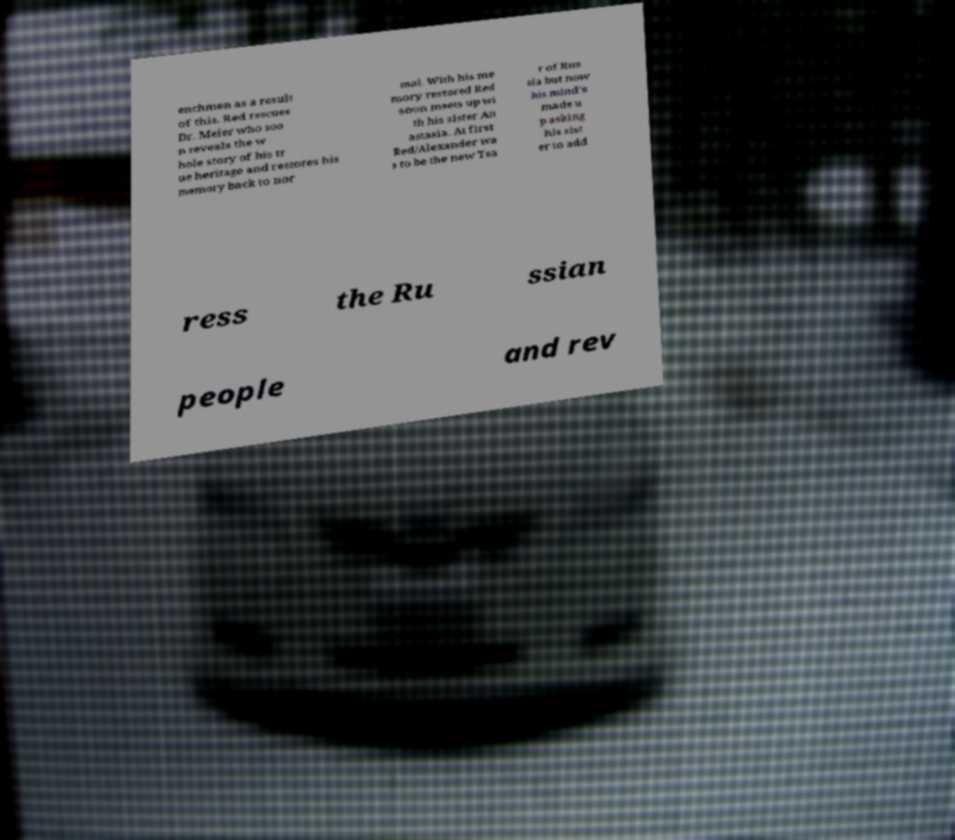Please identify and transcribe the text found in this image. enchmen as a result of this. Red rescues Dr. Meier who soo n reveals the w hole story of his tr ue heritage and restores his memory back to nor mal. With his me mory restored Red soon meets up wi th his sister An astasia. At first Red/Alexander wa s to be the new Tsa r of Rus sia but now his mind's made u p asking his sist er to add ress the Ru ssian people and rev 